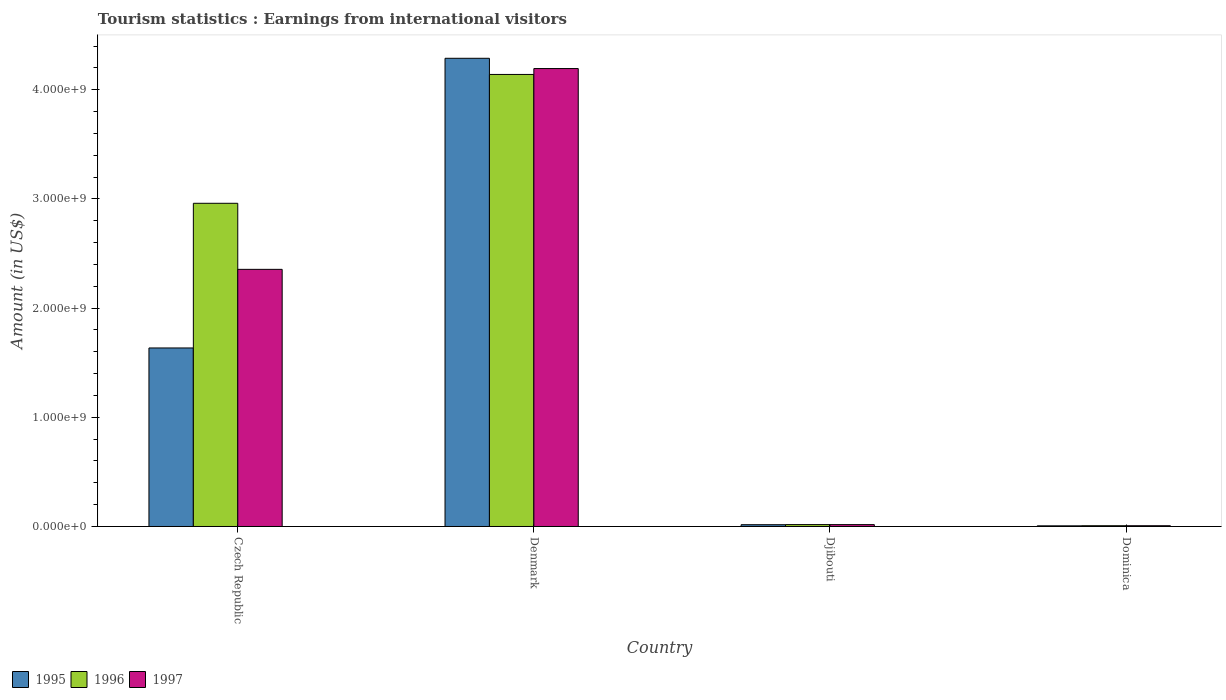How many different coloured bars are there?
Your response must be concise. 3. Are the number of bars per tick equal to the number of legend labels?
Your answer should be compact. Yes. Are the number of bars on each tick of the X-axis equal?
Your answer should be compact. Yes. How many bars are there on the 1st tick from the left?
Make the answer very short. 3. How many bars are there on the 1st tick from the right?
Ensure brevity in your answer.  3. What is the label of the 3rd group of bars from the left?
Make the answer very short. Djibouti. In how many cases, is the number of bars for a given country not equal to the number of legend labels?
Provide a short and direct response. 0. What is the earnings from international visitors in 1995 in Djibouti?
Give a very brief answer. 1.63e+07. Across all countries, what is the maximum earnings from international visitors in 1997?
Keep it short and to the point. 4.19e+09. Across all countries, what is the minimum earnings from international visitors in 1995?
Give a very brief answer. 6.00e+06. In which country was the earnings from international visitors in 1997 minimum?
Your answer should be compact. Dominica. What is the total earnings from international visitors in 1996 in the graph?
Provide a succinct answer. 7.12e+09. What is the difference between the earnings from international visitors in 1995 in Czech Republic and that in Dominica?
Offer a very short reply. 1.63e+09. What is the difference between the earnings from international visitors in 1996 in Djibouti and the earnings from international visitors in 1995 in Czech Republic?
Ensure brevity in your answer.  -1.62e+09. What is the average earnings from international visitors in 1996 per country?
Your response must be concise. 1.78e+09. What is the ratio of the earnings from international visitors in 1997 in Denmark to that in Dominica?
Offer a terse response. 599.14. Is the earnings from international visitors in 1997 in Djibouti less than that in Dominica?
Provide a succinct answer. No. Is the difference between the earnings from international visitors in 1996 in Denmark and Dominica greater than the difference between the earnings from international visitors in 1997 in Denmark and Dominica?
Your answer should be very brief. No. What is the difference between the highest and the second highest earnings from international visitors in 1996?
Your answer should be compact. 1.18e+09. What is the difference between the highest and the lowest earnings from international visitors in 1996?
Your answer should be very brief. 4.13e+09. In how many countries, is the earnings from international visitors in 1997 greater than the average earnings from international visitors in 1997 taken over all countries?
Give a very brief answer. 2. Are all the bars in the graph horizontal?
Offer a very short reply. No. What is the difference between two consecutive major ticks on the Y-axis?
Keep it short and to the point. 1.00e+09. Does the graph contain grids?
Your answer should be very brief. No. How many legend labels are there?
Offer a very short reply. 3. What is the title of the graph?
Ensure brevity in your answer.  Tourism statistics : Earnings from international visitors. What is the label or title of the Y-axis?
Keep it short and to the point. Amount (in US$). What is the Amount (in US$) of 1995 in Czech Republic?
Offer a very short reply. 1.64e+09. What is the Amount (in US$) in 1996 in Czech Republic?
Offer a terse response. 2.96e+09. What is the Amount (in US$) in 1997 in Czech Republic?
Your response must be concise. 2.36e+09. What is the Amount (in US$) in 1995 in Denmark?
Keep it short and to the point. 4.29e+09. What is the Amount (in US$) in 1996 in Denmark?
Give a very brief answer. 4.14e+09. What is the Amount (in US$) of 1997 in Denmark?
Your answer should be very brief. 4.19e+09. What is the Amount (in US$) of 1995 in Djibouti?
Your answer should be compact. 1.63e+07. What is the Amount (in US$) in 1996 in Djibouti?
Provide a short and direct response. 1.73e+07. What is the Amount (in US$) in 1997 in Djibouti?
Make the answer very short. 1.71e+07. What is the Amount (in US$) in 1995 in Dominica?
Keep it short and to the point. 6.00e+06. Across all countries, what is the maximum Amount (in US$) of 1995?
Offer a terse response. 4.29e+09. Across all countries, what is the maximum Amount (in US$) in 1996?
Offer a very short reply. 4.14e+09. Across all countries, what is the maximum Amount (in US$) of 1997?
Make the answer very short. 4.19e+09. Across all countries, what is the minimum Amount (in US$) of 1995?
Offer a very short reply. 6.00e+06. Across all countries, what is the minimum Amount (in US$) of 1997?
Make the answer very short. 7.00e+06. What is the total Amount (in US$) of 1995 in the graph?
Provide a succinct answer. 5.95e+09. What is the total Amount (in US$) of 1996 in the graph?
Ensure brevity in your answer.  7.12e+09. What is the total Amount (in US$) of 1997 in the graph?
Your response must be concise. 6.57e+09. What is the difference between the Amount (in US$) in 1995 in Czech Republic and that in Denmark?
Your answer should be compact. -2.65e+09. What is the difference between the Amount (in US$) of 1996 in Czech Republic and that in Denmark?
Your answer should be very brief. -1.18e+09. What is the difference between the Amount (in US$) in 1997 in Czech Republic and that in Denmark?
Offer a very short reply. -1.84e+09. What is the difference between the Amount (in US$) in 1995 in Czech Republic and that in Djibouti?
Offer a terse response. 1.62e+09. What is the difference between the Amount (in US$) of 1996 in Czech Republic and that in Djibouti?
Your answer should be very brief. 2.94e+09. What is the difference between the Amount (in US$) of 1997 in Czech Republic and that in Djibouti?
Keep it short and to the point. 2.34e+09. What is the difference between the Amount (in US$) of 1995 in Czech Republic and that in Dominica?
Offer a very short reply. 1.63e+09. What is the difference between the Amount (in US$) of 1996 in Czech Republic and that in Dominica?
Make the answer very short. 2.95e+09. What is the difference between the Amount (in US$) in 1997 in Czech Republic and that in Dominica?
Provide a short and direct response. 2.35e+09. What is the difference between the Amount (in US$) of 1995 in Denmark and that in Djibouti?
Provide a succinct answer. 4.27e+09. What is the difference between the Amount (in US$) of 1996 in Denmark and that in Djibouti?
Your answer should be very brief. 4.12e+09. What is the difference between the Amount (in US$) of 1997 in Denmark and that in Djibouti?
Make the answer very short. 4.18e+09. What is the difference between the Amount (in US$) in 1995 in Denmark and that in Dominica?
Provide a short and direct response. 4.28e+09. What is the difference between the Amount (in US$) of 1996 in Denmark and that in Dominica?
Provide a succinct answer. 4.13e+09. What is the difference between the Amount (in US$) of 1997 in Denmark and that in Dominica?
Offer a very short reply. 4.19e+09. What is the difference between the Amount (in US$) of 1995 in Djibouti and that in Dominica?
Your answer should be very brief. 1.03e+07. What is the difference between the Amount (in US$) of 1996 in Djibouti and that in Dominica?
Give a very brief answer. 1.03e+07. What is the difference between the Amount (in US$) in 1997 in Djibouti and that in Dominica?
Your response must be concise. 1.01e+07. What is the difference between the Amount (in US$) in 1995 in Czech Republic and the Amount (in US$) in 1996 in Denmark?
Keep it short and to the point. -2.50e+09. What is the difference between the Amount (in US$) of 1995 in Czech Republic and the Amount (in US$) of 1997 in Denmark?
Offer a terse response. -2.56e+09. What is the difference between the Amount (in US$) in 1996 in Czech Republic and the Amount (in US$) in 1997 in Denmark?
Your answer should be compact. -1.23e+09. What is the difference between the Amount (in US$) of 1995 in Czech Republic and the Amount (in US$) of 1996 in Djibouti?
Your answer should be compact. 1.62e+09. What is the difference between the Amount (in US$) of 1995 in Czech Republic and the Amount (in US$) of 1997 in Djibouti?
Provide a succinct answer. 1.62e+09. What is the difference between the Amount (in US$) of 1996 in Czech Republic and the Amount (in US$) of 1997 in Djibouti?
Provide a succinct answer. 2.94e+09. What is the difference between the Amount (in US$) of 1995 in Czech Republic and the Amount (in US$) of 1996 in Dominica?
Provide a short and direct response. 1.63e+09. What is the difference between the Amount (in US$) of 1995 in Czech Republic and the Amount (in US$) of 1997 in Dominica?
Offer a terse response. 1.63e+09. What is the difference between the Amount (in US$) in 1996 in Czech Republic and the Amount (in US$) in 1997 in Dominica?
Provide a succinct answer. 2.95e+09. What is the difference between the Amount (in US$) of 1995 in Denmark and the Amount (in US$) of 1996 in Djibouti?
Provide a short and direct response. 4.27e+09. What is the difference between the Amount (in US$) of 1995 in Denmark and the Amount (in US$) of 1997 in Djibouti?
Make the answer very short. 4.27e+09. What is the difference between the Amount (in US$) of 1996 in Denmark and the Amount (in US$) of 1997 in Djibouti?
Offer a terse response. 4.12e+09. What is the difference between the Amount (in US$) in 1995 in Denmark and the Amount (in US$) in 1996 in Dominica?
Give a very brief answer. 4.28e+09. What is the difference between the Amount (in US$) of 1995 in Denmark and the Amount (in US$) of 1997 in Dominica?
Offer a terse response. 4.28e+09. What is the difference between the Amount (in US$) of 1996 in Denmark and the Amount (in US$) of 1997 in Dominica?
Give a very brief answer. 4.13e+09. What is the difference between the Amount (in US$) of 1995 in Djibouti and the Amount (in US$) of 1996 in Dominica?
Keep it short and to the point. 9.30e+06. What is the difference between the Amount (in US$) of 1995 in Djibouti and the Amount (in US$) of 1997 in Dominica?
Keep it short and to the point. 9.30e+06. What is the difference between the Amount (in US$) of 1996 in Djibouti and the Amount (in US$) of 1997 in Dominica?
Provide a succinct answer. 1.03e+07. What is the average Amount (in US$) of 1995 per country?
Your answer should be compact. 1.49e+09. What is the average Amount (in US$) in 1996 per country?
Offer a terse response. 1.78e+09. What is the average Amount (in US$) in 1997 per country?
Give a very brief answer. 1.64e+09. What is the difference between the Amount (in US$) in 1995 and Amount (in US$) in 1996 in Czech Republic?
Keep it short and to the point. -1.32e+09. What is the difference between the Amount (in US$) of 1995 and Amount (in US$) of 1997 in Czech Republic?
Offer a terse response. -7.20e+08. What is the difference between the Amount (in US$) of 1996 and Amount (in US$) of 1997 in Czech Republic?
Your response must be concise. 6.05e+08. What is the difference between the Amount (in US$) in 1995 and Amount (in US$) in 1996 in Denmark?
Offer a terse response. 1.48e+08. What is the difference between the Amount (in US$) of 1995 and Amount (in US$) of 1997 in Denmark?
Make the answer very short. 9.40e+07. What is the difference between the Amount (in US$) in 1996 and Amount (in US$) in 1997 in Denmark?
Keep it short and to the point. -5.40e+07. What is the difference between the Amount (in US$) of 1995 and Amount (in US$) of 1996 in Djibouti?
Your response must be concise. -1.00e+06. What is the difference between the Amount (in US$) of 1995 and Amount (in US$) of 1997 in Djibouti?
Provide a short and direct response. -8.00e+05. What is the difference between the Amount (in US$) of 1996 and Amount (in US$) of 1997 in Djibouti?
Provide a succinct answer. 2.00e+05. What is the difference between the Amount (in US$) of 1996 and Amount (in US$) of 1997 in Dominica?
Give a very brief answer. 0. What is the ratio of the Amount (in US$) of 1995 in Czech Republic to that in Denmark?
Keep it short and to the point. 0.38. What is the ratio of the Amount (in US$) of 1996 in Czech Republic to that in Denmark?
Your answer should be very brief. 0.71. What is the ratio of the Amount (in US$) in 1997 in Czech Republic to that in Denmark?
Ensure brevity in your answer.  0.56. What is the ratio of the Amount (in US$) of 1995 in Czech Republic to that in Djibouti?
Your answer should be compact. 100.31. What is the ratio of the Amount (in US$) of 1996 in Czech Republic to that in Djibouti?
Make the answer very short. 171.1. What is the ratio of the Amount (in US$) of 1997 in Czech Republic to that in Djibouti?
Provide a succinct answer. 137.72. What is the ratio of the Amount (in US$) in 1995 in Czech Republic to that in Dominica?
Give a very brief answer. 272.5. What is the ratio of the Amount (in US$) in 1996 in Czech Republic to that in Dominica?
Provide a short and direct response. 422.86. What is the ratio of the Amount (in US$) in 1997 in Czech Republic to that in Dominica?
Give a very brief answer. 336.43. What is the ratio of the Amount (in US$) in 1995 in Denmark to that in Djibouti?
Ensure brevity in your answer.  263.07. What is the ratio of the Amount (in US$) of 1996 in Denmark to that in Djibouti?
Offer a very short reply. 239.31. What is the ratio of the Amount (in US$) in 1997 in Denmark to that in Djibouti?
Your answer should be very brief. 245.26. What is the ratio of the Amount (in US$) of 1995 in Denmark to that in Dominica?
Offer a terse response. 714.67. What is the ratio of the Amount (in US$) of 1996 in Denmark to that in Dominica?
Give a very brief answer. 591.43. What is the ratio of the Amount (in US$) in 1997 in Denmark to that in Dominica?
Offer a very short reply. 599.14. What is the ratio of the Amount (in US$) in 1995 in Djibouti to that in Dominica?
Keep it short and to the point. 2.72. What is the ratio of the Amount (in US$) of 1996 in Djibouti to that in Dominica?
Your answer should be compact. 2.47. What is the ratio of the Amount (in US$) of 1997 in Djibouti to that in Dominica?
Your answer should be compact. 2.44. What is the difference between the highest and the second highest Amount (in US$) of 1995?
Your answer should be very brief. 2.65e+09. What is the difference between the highest and the second highest Amount (in US$) of 1996?
Offer a terse response. 1.18e+09. What is the difference between the highest and the second highest Amount (in US$) of 1997?
Provide a succinct answer. 1.84e+09. What is the difference between the highest and the lowest Amount (in US$) of 1995?
Provide a succinct answer. 4.28e+09. What is the difference between the highest and the lowest Amount (in US$) of 1996?
Provide a succinct answer. 4.13e+09. What is the difference between the highest and the lowest Amount (in US$) of 1997?
Provide a short and direct response. 4.19e+09. 